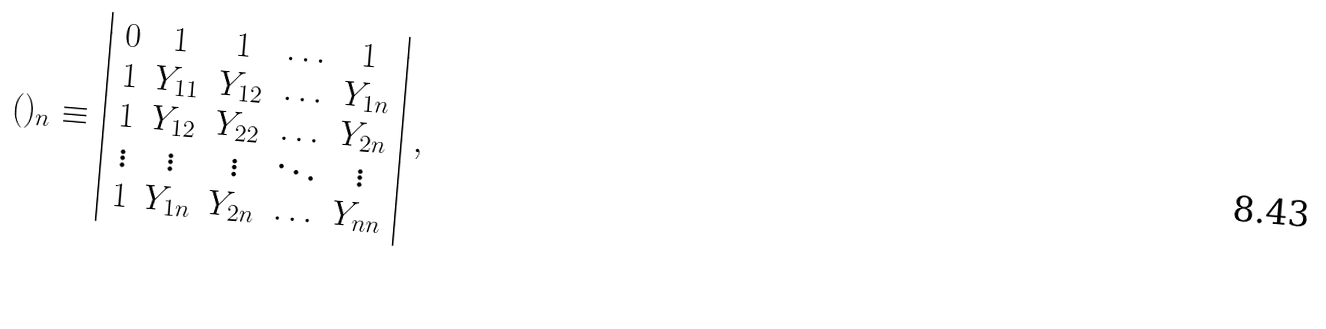<formula> <loc_0><loc_0><loc_500><loc_500>( ) _ { n } \equiv \left | \begin{array} { c c c c c } { 0 } & { 1 } & { 1 } & { \dots } & { 1 } \\ { 1 } & { { Y _ { 1 1 } } } & { { Y _ { 1 2 } } } & { \dots } & { { Y _ { 1 n } } } \\ { 1 } & { { Y _ { 1 2 } } } & { { Y _ { 2 2 } } } & { \dots } & { { Y _ { 2 n } } } \\ { \vdots } & { \vdots } & { \vdots } & { \ddots } & { \vdots } \\ { 1 } & { { Y _ { 1 n } } } & { { Y _ { 2 n } } } & { \dots } & { { Y _ { n n } } } \end{array} \right | ,</formula> 